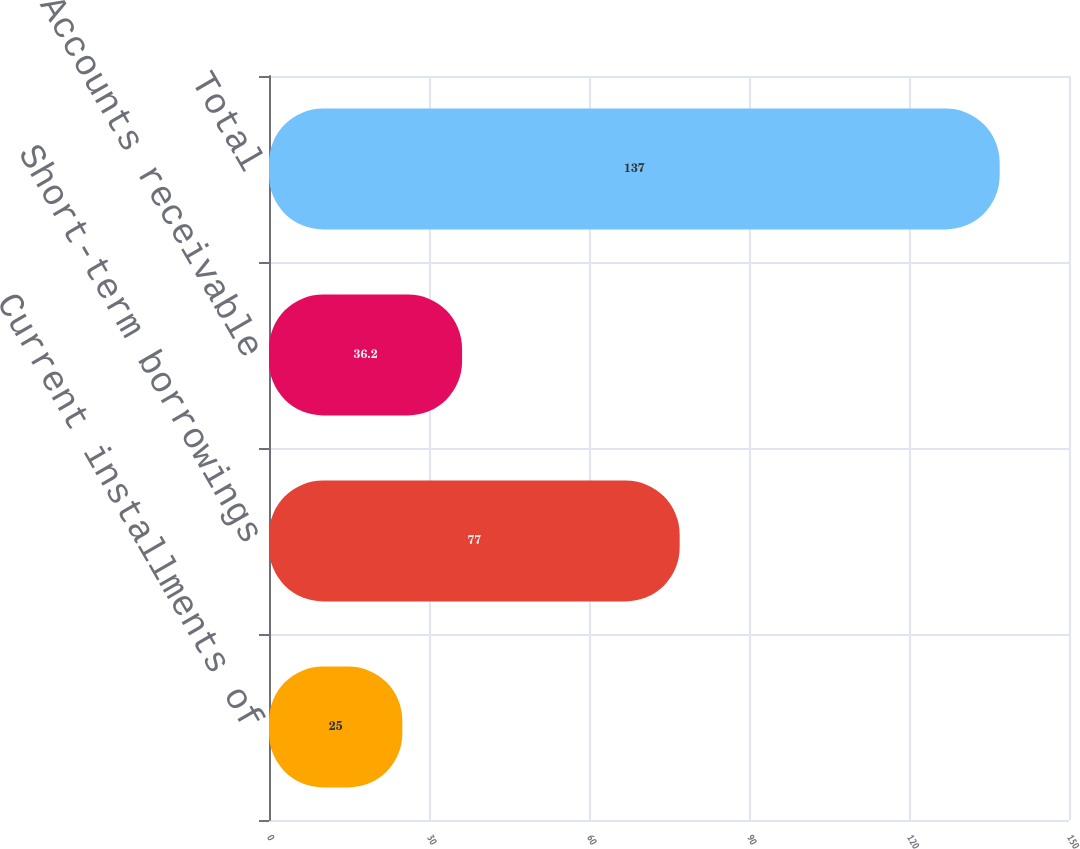<chart> <loc_0><loc_0><loc_500><loc_500><bar_chart><fcel>Current installments of<fcel>Short-term borrowings<fcel>Accounts receivable<fcel>Total<nl><fcel>25<fcel>77<fcel>36.2<fcel>137<nl></chart> 